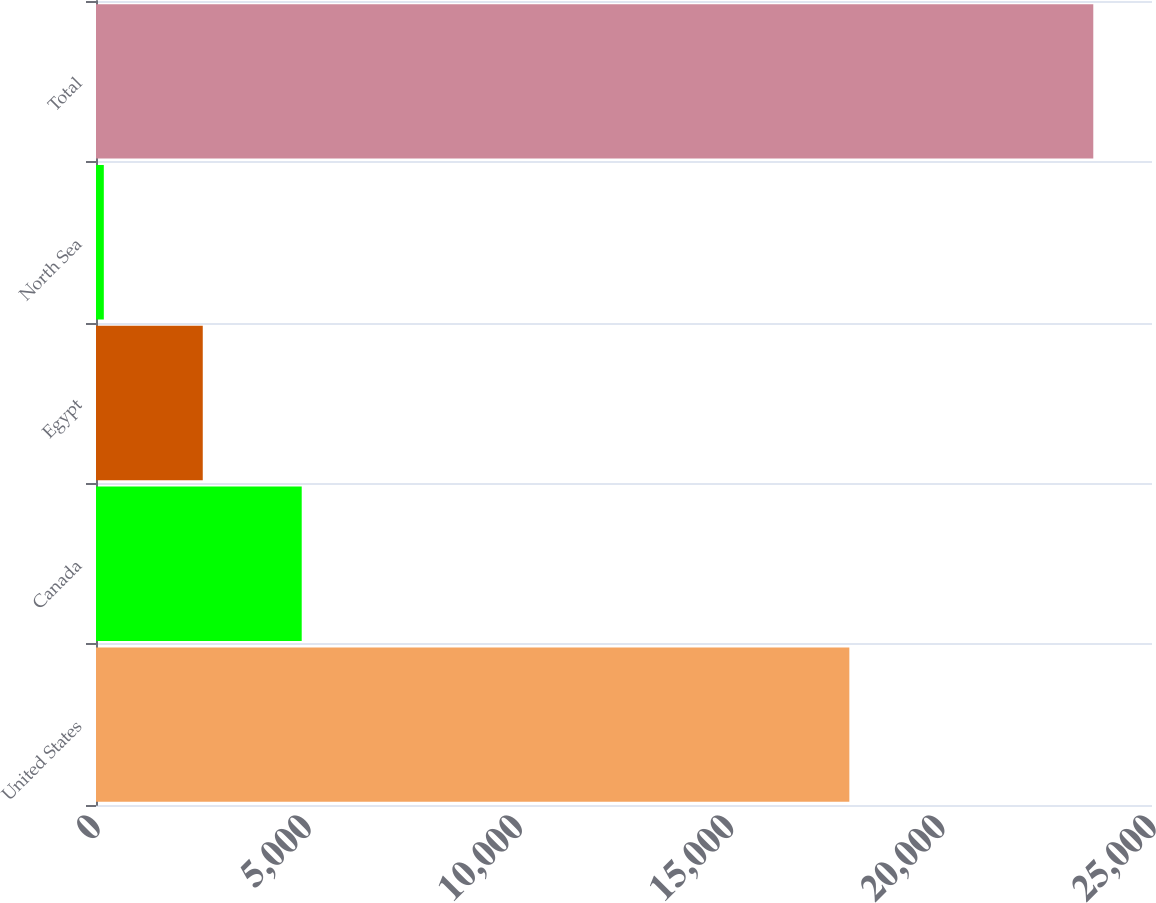Convert chart to OTSL. <chart><loc_0><loc_0><loc_500><loc_500><bar_chart><fcel>United States<fcel>Canada<fcel>Egypt<fcel>North Sea<fcel>Total<nl><fcel>17835<fcel>4870<fcel>2527.5<fcel>185<fcel>23610<nl></chart> 